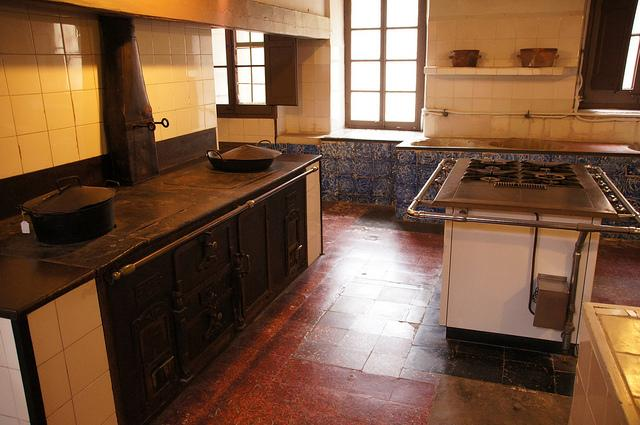Where would a kitchen like this be located? house 